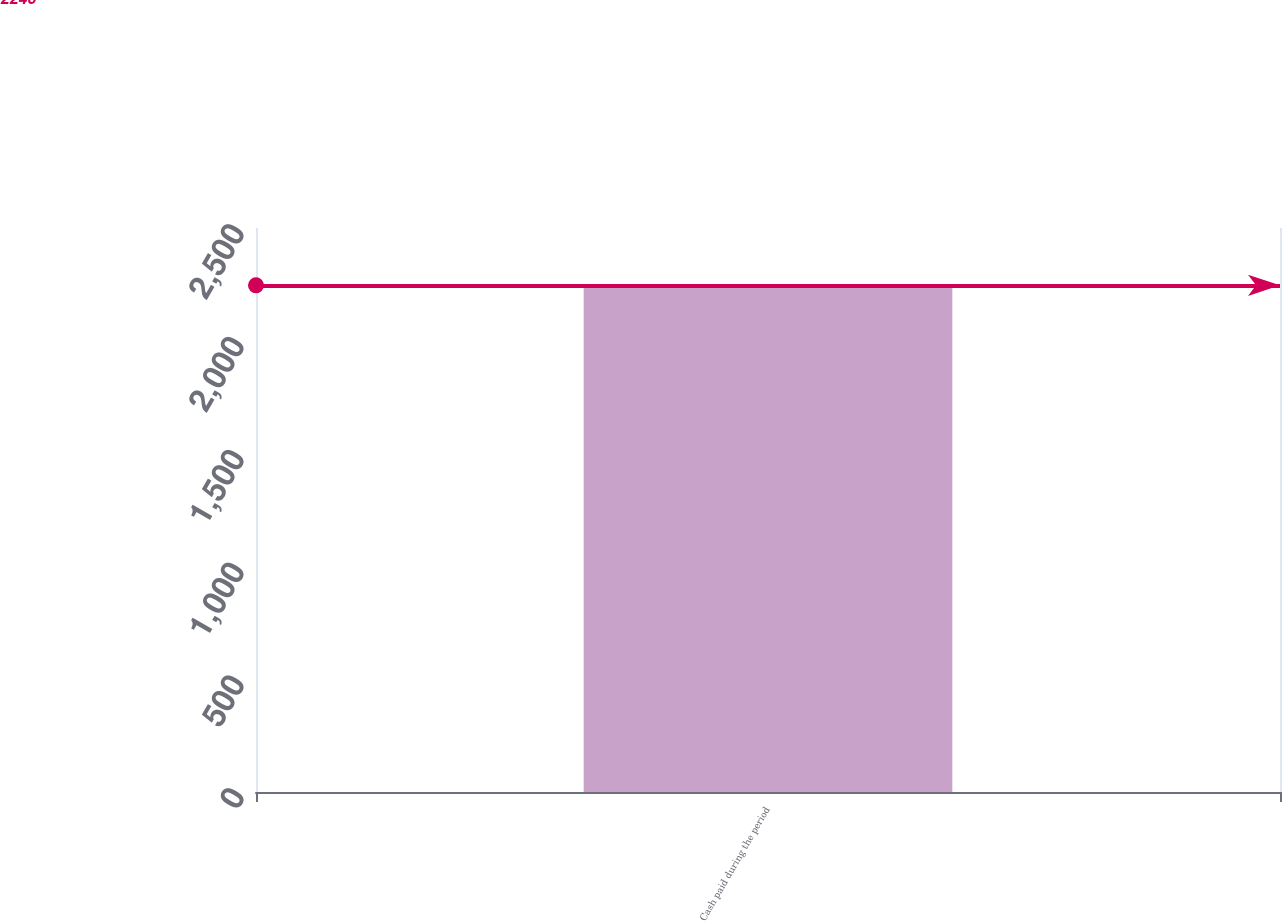Convert chart to OTSL. <chart><loc_0><loc_0><loc_500><loc_500><bar_chart><fcel>Cash paid during the period<nl><fcel>2246<nl></chart> 